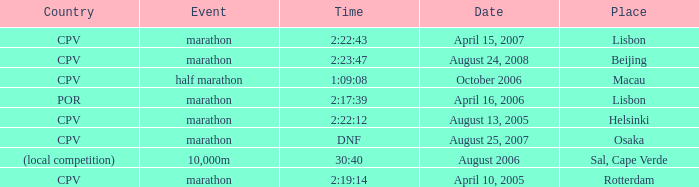What is the Event labeled Country of (local competition)? 10,000m. 